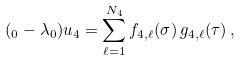<formula> <loc_0><loc_0><loc_500><loc_500>( \L _ { 0 } - \lambda _ { 0 } ) u _ { 4 } = \sum _ { \ell = 1 } ^ { N _ { 4 } } f _ { 4 , \ell } ( \sigma ) \, g _ { 4 , \ell } ( \tau ) \, ,</formula> 